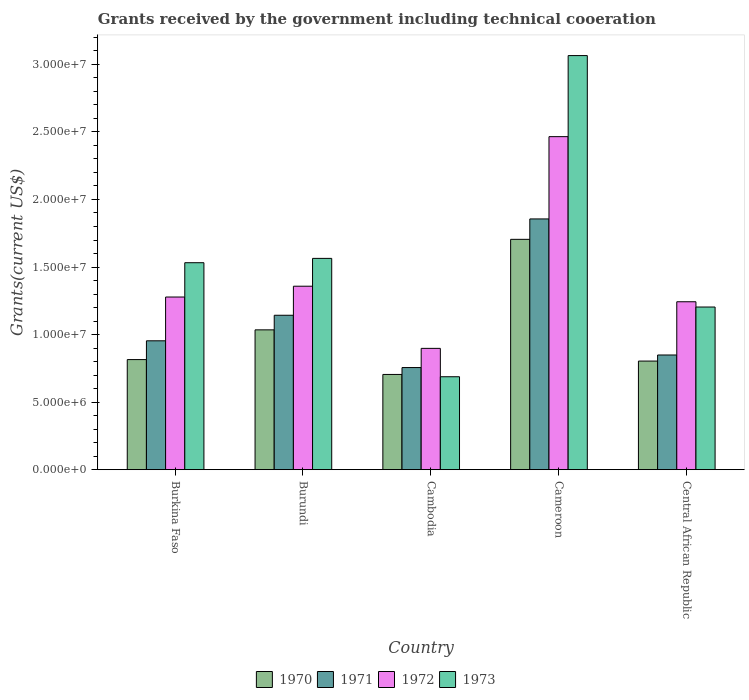How many groups of bars are there?
Ensure brevity in your answer.  5. Are the number of bars on each tick of the X-axis equal?
Your answer should be compact. Yes. How many bars are there on the 2nd tick from the right?
Make the answer very short. 4. What is the label of the 2nd group of bars from the left?
Make the answer very short. Burundi. What is the total grants received by the government in 1971 in Burkina Faso?
Give a very brief answer. 9.54e+06. Across all countries, what is the maximum total grants received by the government in 1971?
Your answer should be compact. 1.86e+07. Across all countries, what is the minimum total grants received by the government in 1972?
Your answer should be very brief. 8.98e+06. In which country was the total grants received by the government in 1973 maximum?
Provide a succinct answer. Cameroon. In which country was the total grants received by the government in 1970 minimum?
Give a very brief answer. Cambodia. What is the total total grants received by the government in 1973 in the graph?
Make the answer very short. 8.05e+07. What is the difference between the total grants received by the government in 1973 in Cambodia and that in Cameroon?
Keep it short and to the point. -2.38e+07. What is the difference between the total grants received by the government in 1973 in Cambodia and the total grants received by the government in 1970 in Cameroon?
Your answer should be very brief. -1.02e+07. What is the average total grants received by the government in 1971 per country?
Keep it short and to the point. 1.11e+07. What is the difference between the total grants received by the government of/in 1972 and total grants received by the government of/in 1971 in Cambodia?
Provide a succinct answer. 1.42e+06. What is the ratio of the total grants received by the government in 1971 in Burundi to that in Cambodia?
Ensure brevity in your answer.  1.51. Is the difference between the total grants received by the government in 1972 in Burundi and Central African Republic greater than the difference between the total grants received by the government in 1971 in Burundi and Central African Republic?
Make the answer very short. No. What is the difference between the highest and the second highest total grants received by the government in 1972?
Your answer should be compact. 1.19e+07. What is the difference between the highest and the lowest total grants received by the government in 1972?
Keep it short and to the point. 1.57e+07. In how many countries, is the total grants received by the government in 1970 greater than the average total grants received by the government in 1970 taken over all countries?
Make the answer very short. 2. What does the 4th bar from the left in Cameroon represents?
Offer a terse response. 1973. What does the 2nd bar from the right in Burkina Faso represents?
Your answer should be very brief. 1972. Is it the case that in every country, the sum of the total grants received by the government in 1971 and total grants received by the government in 1972 is greater than the total grants received by the government in 1970?
Ensure brevity in your answer.  Yes. Are all the bars in the graph horizontal?
Provide a succinct answer. No. What is the difference between two consecutive major ticks on the Y-axis?
Offer a terse response. 5.00e+06. Are the values on the major ticks of Y-axis written in scientific E-notation?
Your answer should be compact. Yes. Does the graph contain any zero values?
Your answer should be compact. No. How are the legend labels stacked?
Your response must be concise. Horizontal. What is the title of the graph?
Your response must be concise. Grants received by the government including technical cooeration. Does "1964" appear as one of the legend labels in the graph?
Provide a succinct answer. No. What is the label or title of the Y-axis?
Make the answer very short. Grants(current US$). What is the Grants(current US$) in 1970 in Burkina Faso?
Provide a short and direct response. 8.15e+06. What is the Grants(current US$) in 1971 in Burkina Faso?
Provide a short and direct response. 9.54e+06. What is the Grants(current US$) of 1972 in Burkina Faso?
Provide a short and direct response. 1.28e+07. What is the Grants(current US$) of 1973 in Burkina Faso?
Ensure brevity in your answer.  1.53e+07. What is the Grants(current US$) of 1970 in Burundi?
Keep it short and to the point. 1.04e+07. What is the Grants(current US$) in 1971 in Burundi?
Offer a terse response. 1.14e+07. What is the Grants(current US$) in 1972 in Burundi?
Make the answer very short. 1.36e+07. What is the Grants(current US$) in 1973 in Burundi?
Provide a succinct answer. 1.56e+07. What is the Grants(current US$) of 1970 in Cambodia?
Keep it short and to the point. 7.05e+06. What is the Grants(current US$) in 1971 in Cambodia?
Provide a succinct answer. 7.56e+06. What is the Grants(current US$) of 1972 in Cambodia?
Keep it short and to the point. 8.98e+06. What is the Grants(current US$) of 1973 in Cambodia?
Make the answer very short. 6.88e+06. What is the Grants(current US$) of 1970 in Cameroon?
Offer a very short reply. 1.70e+07. What is the Grants(current US$) of 1971 in Cameroon?
Offer a very short reply. 1.86e+07. What is the Grants(current US$) in 1972 in Cameroon?
Keep it short and to the point. 2.46e+07. What is the Grants(current US$) in 1973 in Cameroon?
Your response must be concise. 3.06e+07. What is the Grants(current US$) of 1970 in Central African Republic?
Provide a short and direct response. 8.04e+06. What is the Grants(current US$) of 1971 in Central African Republic?
Your answer should be compact. 8.49e+06. What is the Grants(current US$) of 1972 in Central African Republic?
Offer a terse response. 1.24e+07. What is the Grants(current US$) of 1973 in Central African Republic?
Your response must be concise. 1.20e+07. Across all countries, what is the maximum Grants(current US$) in 1970?
Offer a very short reply. 1.70e+07. Across all countries, what is the maximum Grants(current US$) in 1971?
Offer a very short reply. 1.86e+07. Across all countries, what is the maximum Grants(current US$) of 1972?
Offer a very short reply. 2.46e+07. Across all countries, what is the maximum Grants(current US$) in 1973?
Your answer should be very brief. 3.06e+07. Across all countries, what is the minimum Grants(current US$) of 1970?
Keep it short and to the point. 7.05e+06. Across all countries, what is the minimum Grants(current US$) in 1971?
Provide a short and direct response. 7.56e+06. Across all countries, what is the minimum Grants(current US$) in 1972?
Provide a succinct answer. 8.98e+06. Across all countries, what is the minimum Grants(current US$) of 1973?
Provide a succinct answer. 6.88e+06. What is the total Grants(current US$) in 1970 in the graph?
Offer a very short reply. 5.06e+07. What is the total Grants(current US$) in 1971 in the graph?
Keep it short and to the point. 5.56e+07. What is the total Grants(current US$) in 1972 in the graph?
Ensure brevity in your answer.  7.24e+07. What is the total Grants(current US$) in 1973 in the graph?
Your answer should be compact. 8.05e+07. What is the difference between the Grants(current US$) in 1970 in Burkina Faso and that in Burundi?
Keep it short and to the point. -2.20e+06. What is the difference between the Grants(current US$) in 1971 in Burkina Faso and that in Burundi?
Your answer should be compact. -1.89e+06. What is the difference between the Grants(current US$) in 1972 in Burkina Faso and that in Burundi?
Give a very brief answer. -8.00e+05. What is the difference between the Grants(current US$) of 1973 in Burkina Faso and that in Burundi?
Your answer should be compact. -3.20e+05. What is the difference between the Grants(current US$) of 1970 in Burkina Faso and that in Cambodia?
Provide a succinct answer. 1.10e+06. What is the difference between the Grants(current US$) of 1971 in Burkina Faso and that in Cambodia?
Make the answer very short. 1.98e+06. What is the difference between the Grants(current US$) of 1972 in Burkina Faso and that in Cambodia?
Keep it short and to the point. 3.80e+06. What is the difference between the Grants(current US$) of 1973 in Burkina Faso and that in Cambodia?
Ensure brevity in your answer.  8.44e+06. What is the difference between the Grants(current US$) in 1970 in Burkina Faso and that in Cameroon?
Keep it short and to the point. -8.90e+06. What is the difference between the Grants(current US$) in 1971 in Burkina Faso and that in Cameroon?
Your answer should be compact. -9.02e+06. What is the difference between the Grants(current US$) in 1972 in Burkina Faso and that in Cameroon?
Provide a short and direct response. -1.19e+07. What is the difference between the Grants(current US$) of 1973 in Burkina Faso and that in Cameroon?
Provide a short and direct response. -1.53e+07. What is the difference between the Grants(current US$) in 1971 in Burkina Faso and that in Central African Republic?
Provide a short and direct response. 1.05e+06. What is the difference between the Grants(current US$) in 1972 in Burkina Faso and that in Central African Republic?
Ensure brevity in your answer.  3.50e+05. What is the difference between the Grants(current US$) of 1973 in Burkina Faso and that in Central African Republic?
Offer a terse response. 3.28e+06. What is the difference between the Grants(current US$) in 1970 in Burundi and that in Cambodia?
Ensure brevity in your answer.  3.30e+06. What is the difference between the Grants(current US$) of 1971 in Burundi and that in Cambodia?
Provide a succinct answer. 3.87e+06. What is the difference between the Grants(current US$) of 1972 in Burundi and that in Cambodia?
Your response must be concise. 4.60e+06. What is the difference between the Grants(current US$) in 1973 in Burundi and that in Cambodia?
Your answer should be compact. 8.76e+06. What is the difference between the Grants(current US$) of 1970 in Burundi and that in Cameroon?
Ensure brevity in your answer.  -6.70e+06. What is the difference between the Grants(current US$) of 1971 in Burundi and that in Cameroon?
Provide a short and direct response. -7.13e+06. What is the difference between the Grants(current US$) of 1972 in Burundi and that in Cameroon?
Make the answer very short. -1.11e+07. What is the difference between the Grants(current US$) in 1973 in Burundi and that in Cameroon?
Make the answer very short. -1.50e+07. What is the difference between the Grants(current US$) of 1970 in Burundi and that in Central African Republic?
Your answer should be compact. 2.31e+06. What is the difference between the Grants(current US$) in 1971 in Burundi and that in Central African Republic?
Offer a very short reply. 2.94e+06. What is the difference between the Grants(current US$) in 1972 in Burundi and that in Central African Republic?
Provide a succinct answer. 1.15e+06. What is the difference between the Grants(current US$) in 1973 in Burundi and that in Central African Republic?
Keep it short and to the point. 3.60e+06. What is the difference between the Grants(current US$) of 1970 in Cambodia and that in Cameroon?
Provide a short and direct response. -1.00e+07. What is the difference between the Grants(current US$) in 1971 in Cambodia and that in Cameroon?
Your answer should be compact. -1.10e+07. What is the difference between the Grants(current US$) in 1972 in Cambodia and that in Cameroon?
Provide a short and direct response. -1.57e+07. What is the difference between the Grants(current US$) in 1973 in Cambodia and that in Cameroon?
Provide a short and direct response. -2.38e+07. What is the difference between the Grants(current US$) in 1970 in Cambodia and that in Central African Republic?
Offer a terse response. -9.90e+05. What is the difference between the Grants(current US$) of 1971 in Cambodia and that in Central African Republic?
Your response must be concise. -9.30e+05. What is the difference between the Grants(current US$) of 1972 in Cambodia and that in Central African Republic?
Your response must be concise. -3.45e+06. What is the difference between the Grants(current US$) in 1973 in Cambodia and that in Central African Republic?
Keep it short and to the point. -5.16e+06. What is the difference between the Grants(current US$) in 1970 in Cameroon and that in Central African Republic?
Make the answer very short. 9.01e+06. What is the difference between the Grants(current US$) of 1971 in Cameroon and that in Central African Republic?
Provide a succinct answer. 1.01e+07. What is the difference between the Grants(current US$) of 1972 in Cameroon and that in Central African Republic?
Your answer should be compact. 1.22e+07. What is the difference between the Grants(current US$) in 1973 in Cameroon and that in Central African Republic?
Your answer should be compact. 1.86e+07. What is the difference between the Grants(current US$) in 1970 in Burkina Faso and the Grants(current US$) in 1971 in Burundi?
Provide a succinct answer. -3.28e+06. What is the difference between the Grants(current US$) of 1970 in Burkina Faso and the Grants(current US$) of 1972 in Burundi?
Make the answer very short. -5.43e+06. What is the difference between the Grants(current US$) in 1970 in Burkina Faso and the Grants(current US$) in 1973 in Burundi?
Your answer should be very brief. -7.49e+06. What is the difference between the Grants(current US$) of 1971 in Burkina Faso and the Grants(current US$) of 1972 in Burundi?
Ensure brevity in your answer.  -4.04e+06. What is the difference between the Grants(current US$) in 1971 in Burkina Faso and the Grants(current US$) in 1973 in Burundi?
Make the answer very short. -6.10e+06. What is the difference between the Grants(current US$) in 1972 in Burkina Faso and the Grants(current US$) in 1973 in Burundi?
Your answer should be very brief. -2.86e+06. What is the difference between the Grants(current US$) of 1970 in Burkina Faso and the Grants(current US$) of 1971 in Cambodia?
Offer a terse response. 5.90e+05. What is the difference between the Grants(current US$) in 1970 in Burkina Faso and the Grants(current US$) in 1972 in Cambodia?
Your answer should be compact. -8.30e+05. What is the difference between the Grants(current US$) in 1970 in Burkina Faso and the Grants(current US$) in 1973 in Cambodia?
Give a very brief answer. 1.27e+06. What is the difference between the Grants(current US$) in 1971 in Burkina Faso and the Grants(current US$) in 1972 in Cambodia?
Keep it short and to the point. 5.60e+05. What is the difference between the Grants(current US$) of 1971 in Burkina Faso and the Grants(current US$) of 1973 in Cambodia?
Offer a terse response. 2.66e+06. What is the difference between the Grants(current US$) in 1972 in Burkina Faso and the Grants(current US$) in 1973 in Cambodia?
Give a very brief answer. 5.90e+06. What is the difference between the Grants(current US$) of 1970 in Burkina Faso and the Grants(current US$) of 1971 in Cameroon?
Offer a terse response. -1.04e+07. What is the difference between the Grants(current US$) of 1970 in Burkina Faso and the Grants(current US$) of 1972 in Cameroon?
Offer a terse response. -1.65e+07. What is the difference between the Grants(current US$) of 1970 in Burkina Faso and the Grants(current US$) of 1973 in Cameroon?
Your response must be concise. -2.25e+07. What is the difference between the Grants(current US$) in 1971 in Burkina Faso and the Grants(current US$) in 1972 in Cameroon?
Keep it short and to the point. -1.51e+07. What is the difference between the Grants(current US$) in 1971 in Burkina Faso and the Grants(current US$) in 1973 in Cameroon?
Ensure brevity in your answer.  -2.11e+07. What is the difference between the Grants(current US$) in 1972 in Burkina Faso and the Grants(current US$) in 1973 in Cameroon?
Keep it short and to the point. -1.79e+07. What is the difference between the Grants(current US$) of 1970 in Burkina Faso and the Grants(current US$) of 1971 in Central African Republic?
Provide a succinct answer. -3.40e+05. What is the difference between the Grants(current US$) of 1970 in Burkina Faso and the Grants(current US$) of 1972 in Central African Republic?
Your answer should be very brief. -4.28e+06. What is the difference between the Grants(current US$) of 1970 in Burkina Faso and the Grants(current US$) of 1973 in Central African Republic?
Give a very brief answer. -3.89e+06. What is the difference between the Grants(current US$) of 1971 in Burkina Faso and the Grants(current US$) of 1972 in Central African Republic?
Give a very brief answer. -2.89e+06. What is the difference between the Grants(current US$) of 1971 in Burkina Faso and the Grants(current US$) of 1973 in Central African Republic?
Offer a very short reply. -2.50e+06. What is the difference between the Grants(current US$) of 1972 in Burkina Faso and the Grants(current US$) of 1973 in Central African Republic?
Offer a terse response. 7.40e+05. What is the difference between the Grants(current US$) in 1970 in Burundi and the Grants(current US$) in 1971 in Cambodia?
Offer a terse response. 2.79e+06. What is the difference between the Grants(current US$) of 1970 in Burundi and the Grants(current US$) of 1972 in Cambodia?
Keep it short and to the point. 1.37e+06. What is the difference between the Grants(current US$) of 1970 in Burundi and the Grants(current US$) of 1973 in Cambodia?
Your response must be concise. 3.47e+06. What is the difference between the Grants(current US$) of 1971 in Burundi and the Grants(current US$) of 1972 in Cambodia?
Your answer should be very brief. 2.45e+06. What is the difference between the Grants(current US$) of 1971 in Burundi and the Grants(current US$) of 1973 in Cambodia?
Make the answer very short. 4.55e+06. What is the difference between the Grants(current US$) of 1972 in Burundi and the Grants(current US$) of 1973 in Cambodia?
Make the answer very short. 6.70e+06. What is the difference between the Grants(current US$) in 1970 in Burundi and the Grants(current US$) in 1971 in Cameroon?
Ensure brevity in your answer.  -8.21e+06. What is the difference between the Grants(current US$) in 1970 in Burundi and the Grants(current US$) in 1972 in Cameroon?
Provide a short and direct response. -1.43e+07. What is the difference between the Grants(current US$) in 1970 in Burundi and the Grants(current US$) in 1973 in Cameroon?
Give a very brief answer. -2.03e+07. What is the difference between the Grants(current US$) of 1971 in Burundi and the Grants(current US$) of 1972 in Cameroon?
Offer a very short reply. -1.32e+07. What is the difference between the Grants(current US$) in 1971 in Burundi and the Grants(current US$) in 1973 in Cameroon?
Provide a short and direct response. -1.92e+07. What is the difference between the Grants(current US$) in 1972 in Burundi and the Grants(current US$) in 1973 in Cameroon?
Your answer should be compact. -1.71e+07. What is the difference between the Grants(current US$) of 1970 in Burundi and the Grants(current US$) of 1971 in Central African Republic?
Offer a very short reply. 1.86e+06. What is the difference between the Grants(current US$) of 1970 in Burundi and the Grants(current US$) of 1972 in Central African Republic?
Your answer should be compact. -2.08e+06. What is the difference between the Grants(current US$) of 1970 in Burundi and the Grants(current US$) of 1973 in Central African Republic?
Ensure brevity in your answer.  -1.69e+06. What is the difference between the Grants(current US$) of 1971 in Burundi and the Grants(current US$) of 1973 in Central African Republic?
Provide a succinct answer. -6.10e+05. What is the difference between the Grants(current US$) in 1972 in Burundi and the Grants(current US$) in 1973 in Central African Republic?
Provide a short and direct response. 1.54e+06. What is the difference between the Grants(current US$) of 1970 in Cambodia and the Grants(current US$) of 1971 in Cameroon?
Your answer should be compact. -1.15e+07. What is the difference between the Grants(current US$) of 1970 in Cambodia and the Grants(current US$) of 1972 in Cameroon?
Keep it short and to the point. -1.76e+07. What is the difference between the Grants(current US$) in 1970 in Cambodia and the Grants(current US$) in 1973 in Cameroon?
Keep it short and to the point. -2.36e+07. What is the difference between the Grants(current US$) of 1971 in Cambodia and the Grants(current US$) of 1972 in Cameroon?
Ensure brevity in your answer.  -1.71e+07. What is the difference between the Grants(current US$) of 1971 in Cambodia and the Grants(current US$) of 1973 in Cameroon?
Your answer should be compact. -2.31e+07. What is the difference between the Grants(current US$) of 1972 in Cambodia and the Grants(current US$) of 1973 in Cameroon?
Offer a terse response. -2.17e+07. What is the difference between the Grants(current US$) of 1970 in Cambodia and the Grants(current US$) of 1971 in Central African Republic?
Make the answer very short. -1.44e+06. What is the difference between the Grants(current US$) in 1970 in Cambodia and the Grants(current US$) in 1972 in Central African Republic?
Ensure brevity in your answer.  -5.38e+06. What is the difference between the Grants(current US$) in 1970 in Cambodia and the Grants(current US$) in 1973 in Central African Republic?
Give a very brief answer. -4.99e+06. What is the difference between the Grants(current US$) in 1971 in Cambodia and the Grants(current US$) in 1972 in Central African Republic?
Your response must be concise. -4.87e+06. What is the difference between the Grants(current US$) of 1971 in Cambodia and the Grants(current US$) of 1973 in Central African Republic?
Provide a succinct answer. -4.48e+06. What is the difference between the Grants(current US$) in 1972 in Cambodia and the Grants(current US$) in 1973 in Central African Republic?
Your answer should be compact. -3.06e+06. What is the difference between the Grants(current US$) in 1970 in Cameroon and the Grants(current US$) in 1971 in Central African Republic?
Provide a short and direct response. 8.56e+06. What is the difference between the Grants(current US$) in 1970 in Cameroon and the Grants(current US$) in 1972 in Central African Republic?
Keep it short and to the point. 4.62e+06. What is the difference between the Grants(current US$) of 1970 in Cameroon and the Grants(current US$) of 1973 in Central African Republic?
Provide a succinct answer. 5.01e+06. What is the difference between the Grants(current US$) of 1971 in Cameroon and the Grants(current US$) of 1972 in Central African Republic?
Offer a very short reply. 6.13e+06. What is the difference between the Grants(current US$) of 1971 in Cameroon and the Grants(current US$) of 1973 in Central African Republic?
Make the answer very short. 6.52e+06. What is the difference between the Grants(current US$) in 1972 in Cameroon and the Grants(current US$) in 1973 in Central African Republic?
Offer a terse response. 1.26e+07. What is the average Grants(current US$) in 1970 per country?
Offer a very short reply. 1.01e+07. What is the average Grants(current US$) in 1971 per country?
Your answer should be very brief. 1.11e+07. What is the average Grants(current US$) of 1972 per country?
Keep it short and to the point. 1.45e+07. What is the average Grants(current US$) of 1973 per country?
Your answer should be compact. 1.61e+07. What is the difference between the Grants(current US$) in 1970 and Grants(current US$) in 1971 in Burkina Faso?
Keep it short and to the point. -1.39e+06. What is the difference between the Grants(current US$) in 1970 and Grants(current US$) in 1972 in Burkina Faso?
Your answer should be very brief. -4.63e+06. What is the difference between the Grants(current US$) of 1970 and Grants(current US$) of 1973 in Burkina Faso?
Offer a very short reply. -7.17e+06. What is the difference between the Grants(current US$) of 1971 and Grants(current US$) of 1972 in Burkina Faso?
Provide a succinct answer. -3.24e+06. What is the difference between the Grants(current US$) of 1971 and Grants(current US$) of 1973 in Burkina Faso?
Provide a succinct answer. -5.78e+06. What is the difference between the Grants(current US$) in 1972 and Grants(current US$) in 1973 in Burkina Faso?
Provide a short and direct response. -2.54e+06. What is the difference between the Grants(current US$) in 1970 and Grants(current US$) in 1971 in Burundi?
Your answer should be very brief. -1.08e+06. What is the difference between the Grants(current US$) in 1970 and Grants(current US$) in 1972 in Burundi?
Your answer should be compact. -3.23e+06. What is the difference between the Grants(current US$) in 1970 and Grants(current US$) in 1973 in Burundi?
Make the answer very short. -5.29e+06. What is the difference between the Grants(current US$) of 1971 and Grants(current US$) of 1972 in Burundi?
Your response must be concise. -2.15e+06. What is the difference between the Grants(current US$) in 1971 and Grants(current US$) in 1973 in Burundi?
Give a very brief answer. -4.21e+06. What is the difference between the Grants(current US$) of 1972 and Grants(current US$) of 1973 in Burundi?
Your response must be concise. -2.06e+06. What is the difference between the Grants(current US$) in 1970 and Grants(current US$) in 1971 in Cambodia?
Provide a short and direct response. -5.10e+05. What is the difference between the Grants(current US$) of 1970 and Grants(current US$) of 1972 in Cambodia?
Give a very brief answer. -1.93e+06. What is the difference between the Grants(current US$) of 1970 and Grants(current US$) of 1973 in Cambodia?
Your answer should be compact. 1.70e+05. What is the difference between the Grants(current US$) in 1971 and Grants(current US$) in 1972 in Cambodia?
Make the answer very short. -1.42e+06. What is the difference between the Grants(current US$) in 1971 and Grants(current US$) in 1973 in Cambodia?
Ensure brevity in your answer.  6.80e+05. What is the difference between the Grants(current US$) of 1972 and Grants(current US$) of 1973 in Cambodia?
Give a very brief answer. 2.10e+06. What is the difference between the Grants(current US$) in 1970 and Grants(current US$) in 1971 in Cameroon?
Your response must be concise. -1.51e+06. What is the difference between the Grants(current US$) in 1970 and Grants(current US$) in 1972 in Cameroon?
Your answer should be very brief. -7.60e+06. What is the difference between the Grants(current US$) of 1970 and Grants(current US$) of 1973 in Cameroon?
Your response must be concise. -1.36e+07. What is the difference between the Grants(current US$) of 1971 and Grants(current US$) of 1972 in Cameroon?
Keep it short and to the point. -6.09e+06. What is the difference between the Grants(current US$) in 1971 and Grants(current US$) in 1973 in Cameroon?
Offer a very short reply. -1.21e+07. What is the difference between the Grants(current US$) of 1972 and Grants(current US$) of 1973 in Cameroon?
Provide a succinct answer. -6.00e+06. What is the difference between the Grants(current US$) in 1970 and Grants(current US$) in 1971 in Central African Republic?
Make the answer very short. -4.50e+05. What is the difference between the Grants(current US$) of 1970 and Grants(current US$) of 1972 in Central African Republic?
Give a very brief answer. -4.39e+06. What is the difference between the Grants(current US$) of 1971 and Grants(current US$) of 1972 in Central African Republic?
Your answer should be compact. -3.94e+06. What is the difference between the Grants(current US$) of 1971 and Grants(current US$) of 1973 in Central African Republic?
Offer a very short reply. -3.55e+06. What is the ratio of the Grants(current US$) of 1970 in Burkina Faso to that in Burundi?
Your answer should be very brief. 0.79. What is the ratio of the Grants(current US$) of 1971 in Burkina Faso to that in Burundi?
Your response must be concise. 0.83. What is the ratio of the Grants(current US$) of 1972 in Burkina Faso to that in Burundi?
Keep it short and to the point. 0.94. What is the ratio of the Grants(current US$) of 1973 in Burkina Faso to that in Burundi?
Your answer should be very brief. 0.98. What is the ratio of the Grants(current US$) of 1970 in Burkina Faso to that in Cambodia?
Give a very brief answer. 1.16. What is the ratio of the Grants(current US$) in 1971 in Burkina Faso to that in Cambodia?
Keep it short and to the point. 1.26. What is the ratio of the Grants(current US$) of 1972 in Burkina Faso to that in Cambodia?
Your answer should be compact. 1.42. What is the ratio of the Grants(current US$) in 1973 in Burkina Faso to that in Cambodia?
Ensure brevity in your answer.  2.23. What is the ratio of the Grants(current US$) in 1970 in Burkina Faso to that in Cameroon?
Offer a terse response. 0.48. What is the ratio of the Grants(current US$) in 1971 in Burkina Faso to that in Cameroon?
Your response must be concise. 0.51. What is the ratio of the Grants(current US$) in 1972 in Burkina Faso to that in Cameroon?
Ensure brevity in your answer.  0.52. What is the ratio of the Grants(current US$) of 1973 in Burkina Faso to that in Cameroon?
Provide a short and direct response. 0.5. What is the ratio of the Grants(current US$) of 1970 in Burkina Faso to that in Central African Republic?
Your response must be concise. 1.01. What is the ratio of the Grants(current US$) of 1971 in Burkina Faso to that in Central African Republic?
Give a very brief answer. 1.12. What is the ratio of the Grants(current US$) in 1972 in Burkina Faso to that in Central African Republic?
Offer a terse response. 1.03. What is the ratio of the Grants(current US$) of 1973 in Burkina Faso to that in Central African Republic?
Make the answer very short. 1.27. What is the ratio of the Grants(current US$) of 1970 in Burundi to that in Cambodia?
Your response must be concise. 1.47. What is the ratio of the Grants(current US$) in 1971 in Burundi to that in Cambodia?
Provide a succinct answer. 1.51. What is the ratio of the Grants(current US$) of 1972 in Burundi to that in Cambodia?
Provide a short and direct response. 1.51. What is the ratio of the Grants(current US$) of 1973 in Burundi to that in Cambodia?
Make the answer very short. 2.27. What is the ratio of the Grants(current US$) in 1970 in Burundi to that in Cameroon?
Keep it short and to the point. 0.61. What is the ratio of the Grants(current US$) of 1971 in Burundi to that in Cameroon?
Offer a very short reply. 0.62. What is the ratio of the Grants(current US$) in 1972 in Burundi to that in Cameroon?
Provide a short and direct response. 0.55. What is the ratio of the Grants(current US$) of 1973 in Burundi to that in Cameroon?
Provide a short and direct response. 0.51. What is the ratio of the Grants(current US$) in 1970 in Burundi to that in Central African Republic?
Keep it short and to the point. 1.29. What is the ratio of the Grants(current US$) in 1971 in Burundi to that in Central African Republic?
Ensure brevity in your answer.  1.35. What is the ratio of the Grants(current US$) of 1972 in Burundi to that in Central African Republic?
Provide a succinct answer. 1.09. What is the ratio of the Grants(current US$) in 1973 in Burundi to that in Central African Republic?
Your answer should be very brief. 1.3. What is the ratio of the Grants(current US$) of 1970 in Cambodia to that in Cameroon?
Give a very brief answer. 0.41. What is the ratio of the Grants(current US$) in 1971 in Cambodia to that in Cameroon?
Offer a terse response. 0.41. What is the ratio of the Grants(current US$) in 1972 in Cambodia to that in Cameroon?
Keep it short and to the point. 0.36. What is the ratio of the Grants(current US$) in 1973 in Cambodia to that in Cameroon?
Provide a short and direct response. 0.22. What is the ratio of the Grants(current US$) of 1970 in Cambodia to that in Central African Republic?
Your answer should be compact. 0.88. What is the ratio of the Grants(current US$) of 1971 in Cambodia to that in Central African Republic?
Keep it short and to the point. 0.89. What is the ratio of the Grants(current US$) in 1972 in Cambodia to that in Central African Republic?
Provide a succinct answer. 0.72. What is the ratio of the Grants(current US$) of 1973 in Cambodia to that in Central African Republic?
Ensure brevity in your answer.  0.57. What is the ratio of the Grants(current US$) in 1970 in Cameroon to that in Central African Republic?
Keep it short and to the point. 2.12. What is the ratio of the Grants(current US$) in 1971 in Cameroon to that in Central African Republic?
Keep it short and to the point. 2.19. What is the ratio of the Grants(current US$) in 1972 in Cameroon to that in Central African Republic?
Your response must be concise. 1.98. What is the ratio of the Grants(current US$) in 1973 in Cameroon to that in Central African Republic?
Offer a terse response. 2.55. What is the difference between the highest and the second highest Grants(current US$) of 1970?
Your answer should be compact. 6.70e+06. What is the difference between the highest and the second highest Grants(current US$) of 1971?
Offer a very short reply. 7.13e+06. What is the difference between the highest and the second highest Grants(current US$) of 1972?
Your response must be concise. 1.11e+07. What is the difference between the highest and the second highest Grants(current US$) in 1973?
Make the answer very short. 1.50e+07. What is the difference between the highest and the lowest Grants(current US$) in 1971?
Give a very brief answer. 1.10e+07. What is the difference between the highest and the lowest Grants(current US$) in 1972?
Keep it short and to the point. 1.57e+07. What is the difference between the highest and the lowest Grants(current US$) in 1973?
Give a very brief answer. 2.38e+07. 